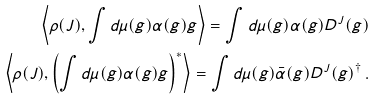Convert formula to latex. <formula><loc_0><loc_0><loc_500><loc_500>\left \langle \rho ( J ) , \int d \mu ( g ) \alpha ( g ) g \right \rangle = \int d \mu ( g ) \alpha ( g ) D ^ { J } ( g ) \\ \left \langle \rho ( J ) , \left ( \int d \mu ( g ) \alpha ( g ) g \right ) ^ { * } \right \rangle = \int d \mu ( g ) \bar { \alpha } ( g ) D ^ { J } ( g ) ^ { \dagger } \, .</formula> 